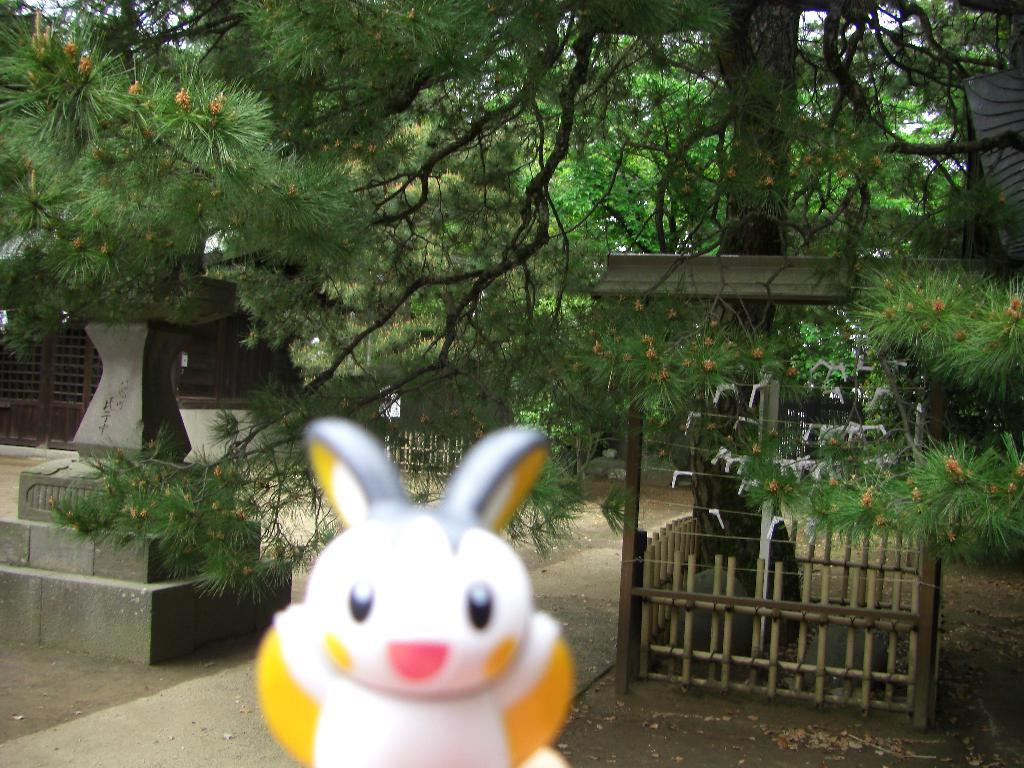What is the main subject in the center of the image? There is a toy in the center of the image. What can be seen in the background of the image? There are statues, trees, a narrow lane, fencing, and a house in the background of the image. What type of skin can be seen on the toy in the image? The toy in the image does not have skin, as it is likely an inanimate object. 